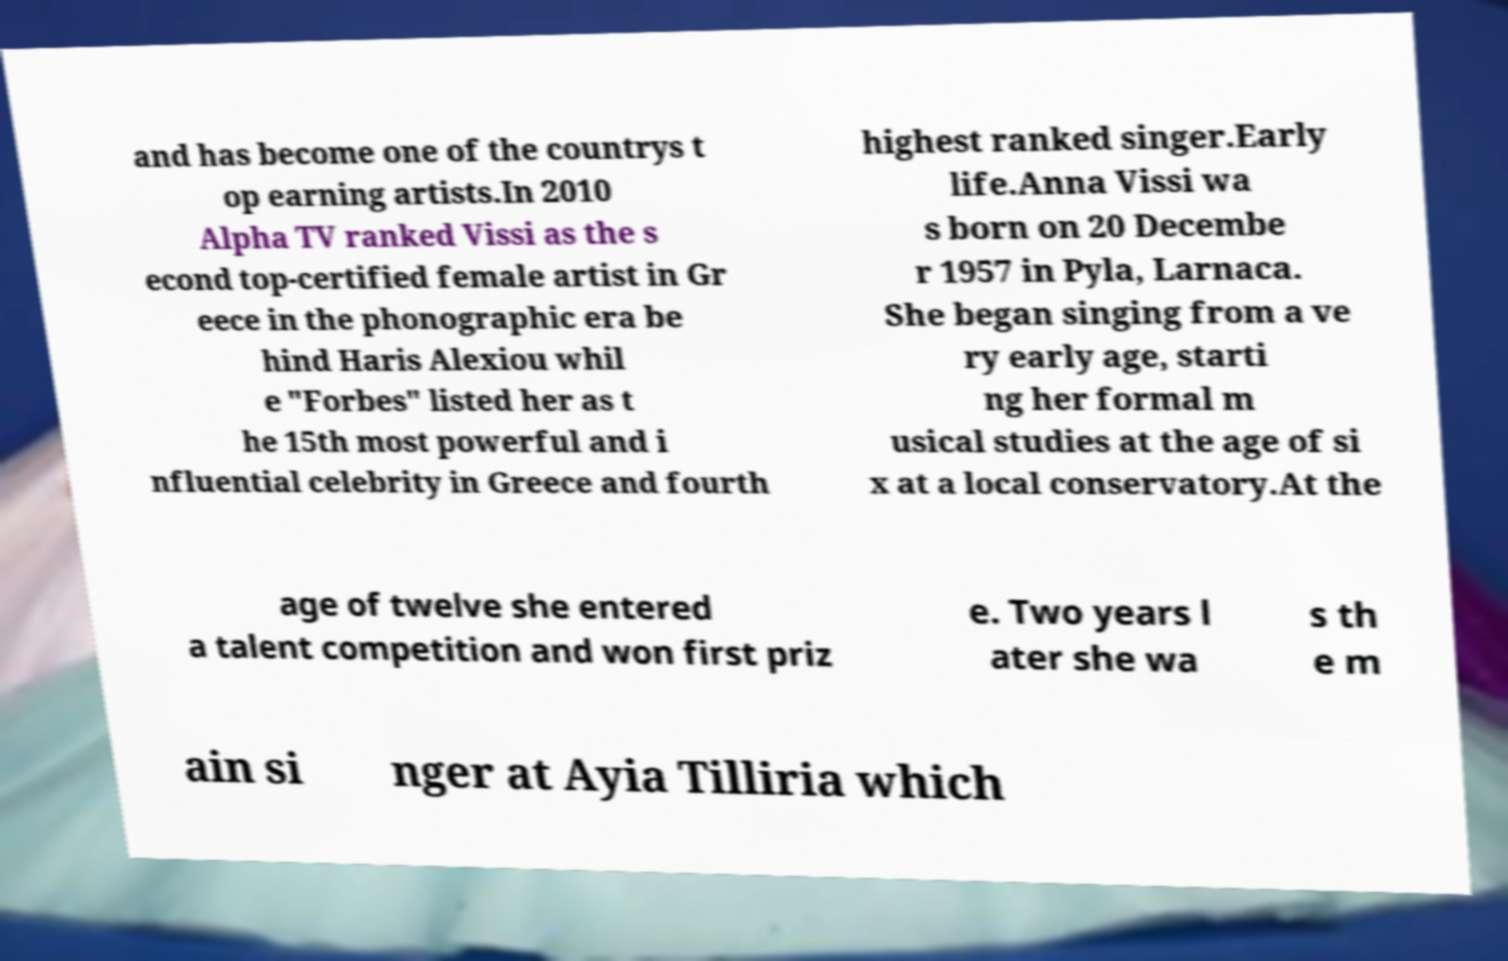Please identify and transcribe the text found in this image. and has become one of the countrys t op earning artists.In 2010 Alpha TV ranked Vissi as the s econd top-certified female artist in Gr eece in the phonographic era be hind Haris Alexiou whil e "Forbes" listed her as t he 15th most powerful and i nfluential celebrity in Greece and fourth highest ranked singer.Early life.Anna Vissi wa s born on 20 Decembe r 1957 in Pyla, Larnaca. She began singing from a ve ry early age, starti ng her formal m usical studies at the age of si x at a local conservatory.At the age of twelve she entered a talent competition and won first priz e. Two years l ater she wa s th e m ain si nger at Ayia Tilliria which 